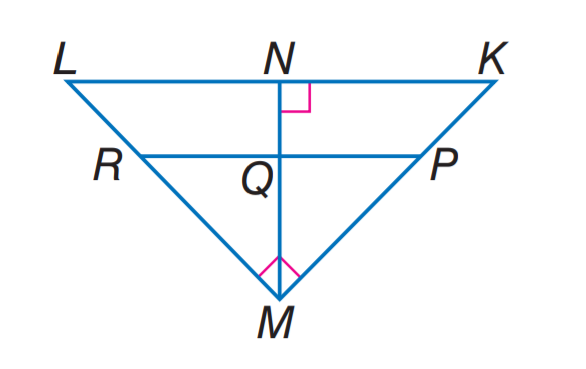Answer the mathemtical geometry problem and directly provide the correct option letter.
Question: If P R \parallel K L, K N = 9, L N = 16, and P M = 2K P, find M N.
Choices: A: 9 B: 12 C: 15 D: 16 B 